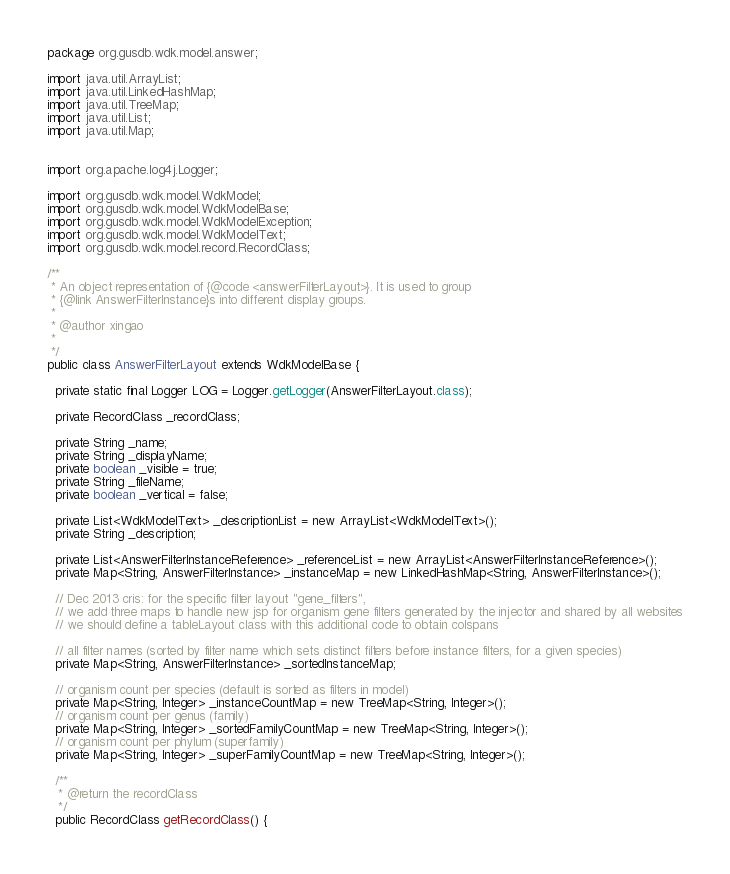<code> <loc_0><loc_0><loc_500><loc_500><_Java_>package org.gusdb.wdk.model.answer;

import java.util.ArrayList;
import java.util.LinkedHashMap;
import java.util.TreeMap;
import java.util.List;
import java.util.Map;


import org.apache.log4j.Logger;

import org.gusdb.wdk.model.WdkModel;
import org.gusdb.wdk.model.WdkModelBase;
import org.gusdb.wdk.model.WdkModelException;
import org.gusdb.wdk.model.WdkModelText;
import org.gusdb.wdk.model.record.RecordClass;

/**
 * An object representation of {@code <answerFilterLayout>}. It is used to group
 * {@link AnswerFilterInstance}s into different display groups.
 * 
 * @author xingao
 * 
 */
public class AnswerFilterLayout extends WdkModelBase {

  private static final Logger LOG = Logger.getLogger(AnswerFilterLayout.class);
  
  private RecordClass _recordClass;

  private String _name;
  private String _displayName;
  private boolean _visible = true;
  private String _fileName;
  private boolean _vertical = false;

  private List<WdkModelText> _descriptionList = new ArrayList<WdkModelText>();
  private String _description;

  private List<AnswerFilterInstanceReference> _referenceList = new ArrayList<AnswerFilterInstanceReference>();
  private Map<String, AnswerFilterInstance> _instanceMap = new LinkedHashMap<String, AnswerFilterInstance>();

  // Dec 2013 cris: for the specific filter layout "gene_filters", 
  // we add three maps to handle new jsp for organism gene filters generated by the injector and shared by all websites
  // we should define a tableLayout class with this additional code to obtain colspans

  // all filter names (sorted by filter name which sets distinct filters before instance filters, for a given species)
  private Map<String, AnswerFilterInstance> _sortedInstanceMap;

  // organism count per species (default is sorted as filters in model)
  private Map<String, Integer> _instanceCountMap = new TreeMap<String, Integer>();
  // organism count per genus (family)
  private Map<String, Integer> _sortedFamilyCountMap = new TreeMap<String, Integer>();
  // organism count per phylum (superfamily)
  private Map<String, Integer> _superFamilyCountMap = new TreeMap<String, Integer>();

  /**
   * @return the recordClass
   */
  public RecordClass getRecordClass() {</code> 